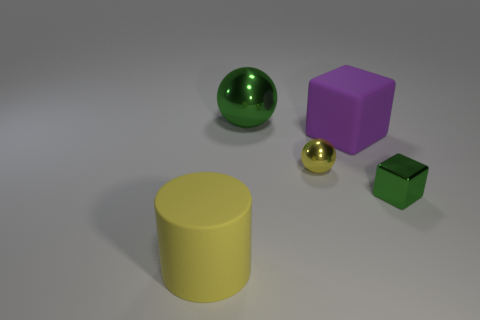What color is the small metal object behind the small green shiny thing?
Offer a very short reply. Yellow. What number of large yellow metal spheres are there?
Offer a very short reply. 0. Is there a tiny sphere that is on the left side of the small metal object that is behind the object that is right of the purple rubber thing?
Provide a short and direct response. No. There is a yellow object that is the same size as the green cube; what is its shape?
Make the answer very short. Sphere. What number of other objects are there of the same color as the tiny block?
Give a very brief answer. 1. What is the tiny green object made of?
Offer a very short reply. Metal. What number of other things are made of the same material as the tiny green block?
Offer a terse response. 2. What size is the object that is both to the left of the purple rubber object and right of the large shiny sphere?
Provide a succinct answer. Small. There is a large rubber object behind the large object in front of the small sphere; what shape is it?
Provide a short and direct response. Cube. Is there any other thing that has the same shape as the yellow rubber thing?
Ensure brevity in your answer.  No. 